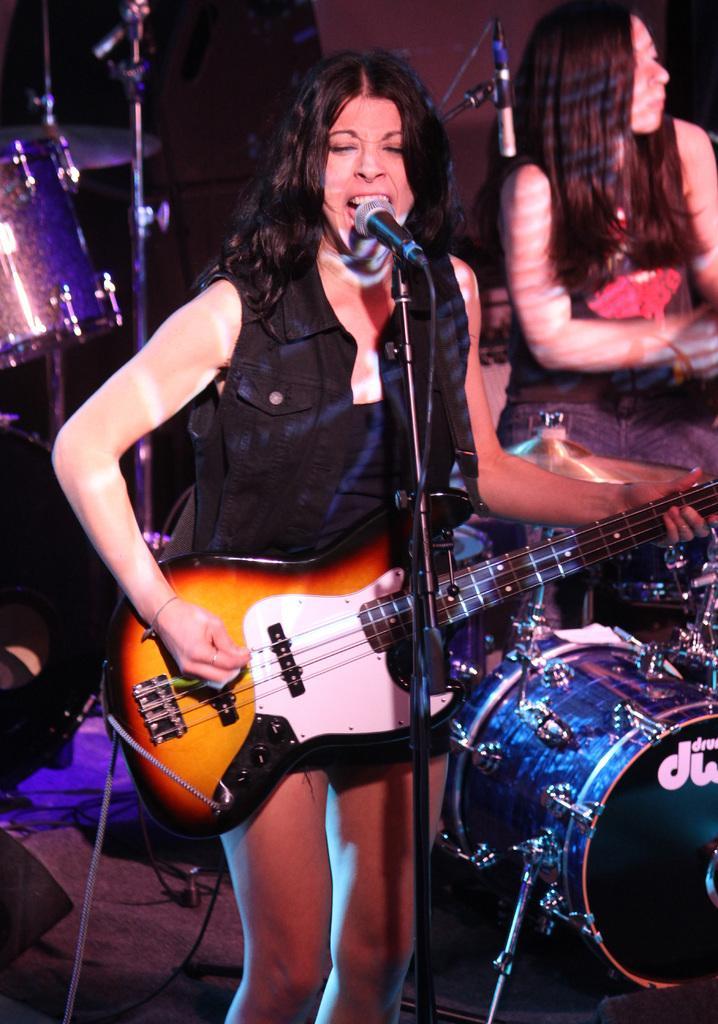Please provide a concise description of this image. This picture shows a woman standing and playing guitar han and singing with the help of a microphone and we see other woman seated on the back and we see few drums 